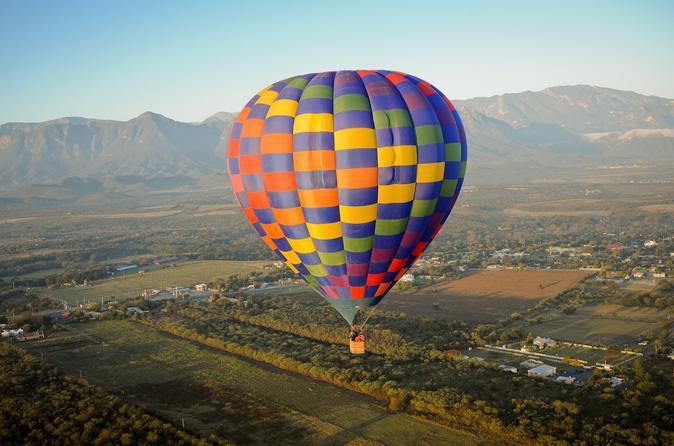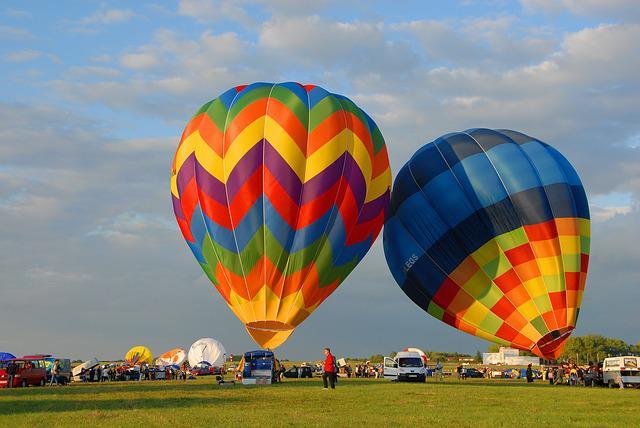The first image is the image on the left, the second image is the image on the right. For the images shown, is this caption "There are at least four balloons in the image on the left." true? Answer yes or no. No. The first image is the image on the left, the second image is the image on the right. Analyze the images presented: Is the assertion "In one image, a face is designed on the side of a large yellow hot-air balloon." valid? Answer yes or no. No. 